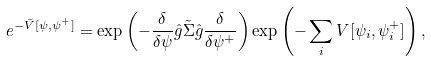Convert formula to latex. <formula><loc_0><loc_0><loc_500><loc_500>e ^ { - \bar { V } [ \psi , \psi ^ { + } ] } = \exp \left ( - \frac { \delta } { \delta \psi } \hat { g } \tilde { \Sigma } \hat { g } \frac { \delta } { \delta \psi ^ { + } } \right ) \exp \left ( - \sum _ { i } V [ \psi _ { i } , \psi ^ { + } _ { i } ] \right ) ,</formula> 